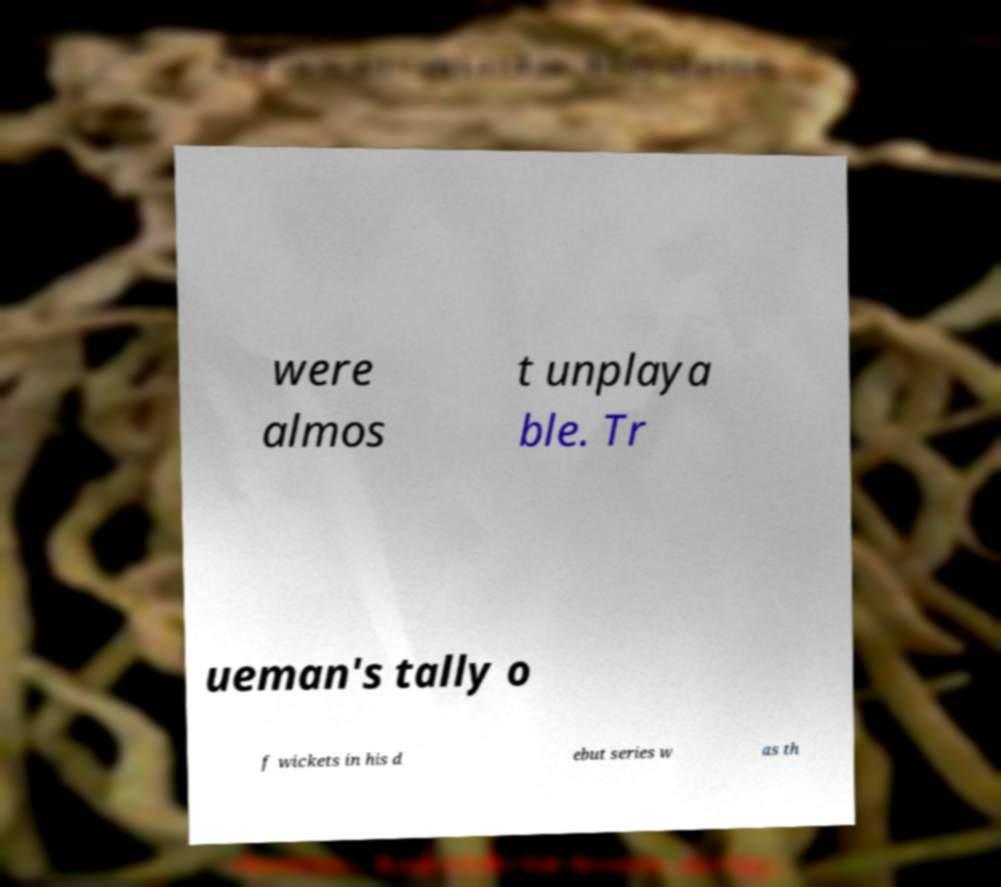For documentation purposes, I need the text within this image transcribed. Could you provide that? were almos t unplaya ble. Tr ueman's tally o f wickets in his d ebut series w as th 